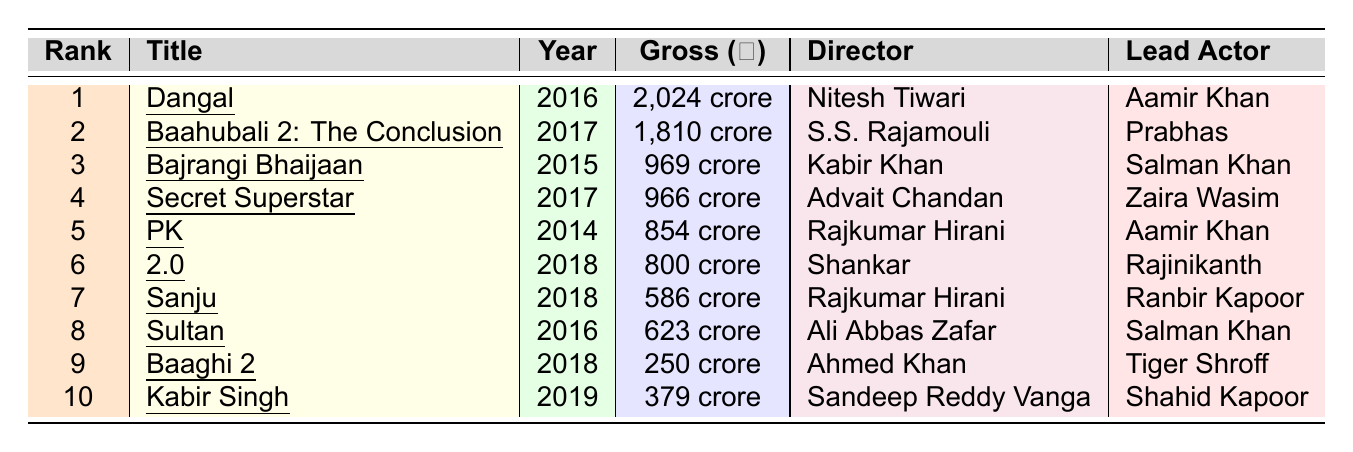What is the gross collection of "Dangal"? The table lists "Dangal" with a gross collection of ₹2,024 crore.
Answer: ₹2,024 crore Who directed "PK"? The table shows that "PK" was directed by Rajkumar Hirani.
Answer: Rajkumar Hirani Which film was released in 2018 and grossed more than ₹500 crore? Looking at the 2018 releases, "2.0" grossed ₹800 crore and "Sanju" grossed ₹586 crore, both above ₹500 crore.
Answer: 2.0 and Sanju What is the difference in gross collections between "Baahubali 2" and "Bajrangi Bhaijaan"? "Baahubali 2" grossed ₹1,810 crore and "Bajrangi Bhaijaan" grossed ₹969 crore. The difference is ₹1,810 crore - ₹969 crore = ₹841 crore.
Answer: ₹841 crore Is "Kabir Singh" the only film in the top ten that has a lead actor from the Kapoor family? The table indicates that "Kabir Singh" features Shahid Kapoor, who is a member of the Kapoor family, and it is the only film in the list featuring a Kapoor as the lead.
Answer: Yes Which director has the most films in the top 10? Upon reviewing the table, Rajkumar Hirani directed two films: "PK" and "Sanju," which is the highest count among all directors listed.
Answer: Rajkumar Hirani What is the average gross collection of the films released in 2016? The films released in 2016 are "Dangal" (₹2,024 crore), "Sultan" (₹623 crore). Their total gross is ₹2,024 crore + ₹623 crore = ₹2,647 crore. The average is ₹2,647 crore / 2 = ₹1,323.5 crore.
Answer: ₹1,323.5 crore Which film ranks 6th, and what is its gross collection? The film that ranks 6th is "2.0," and its gross collection is ₹800 crore according to the table.
Answer: 2.0, ₹800 crore How many films in the top 10 were released in 2017? From the list, two films were released in 2017: "Baahubali 2: The Conclusion" and "Secret Superstar." Therefore, there are two films released in that year.
Answer: 2 Which film has the highest gross collection among films released on a holiday? The table does not provide information regarding which films were released on holidays, thus making this question unanswerable with the current data.
Answer: Cannot determine 